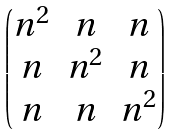Convert formula to latex. <formula><loc_0><loc_0><loc_500><loc_500>\begin{pmatrix} n ^ { 2 } & n & n \\ n & n ^ { 2 } & n \\ n & n & n ^ { 2 } \end{pmatrix}</formula> 